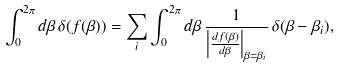Convert formula to latex. <formula><loc_0><loc_0><loc_500><loc_500>\int _ { 0 } ^ { 2 \pi } d \beta \, \delta ( f ( \beta ) ) = \sum _ { i } \int _ { 0 } ^ { 2 \pi } d \beta \, \frac { 1 } { \left | \frac { d f ( \beta ) } { d \beta } \right | _ { \beta = \beta _ { i } } } \, \delta ( \beta - \beta _ { i } ) ,</formula> 